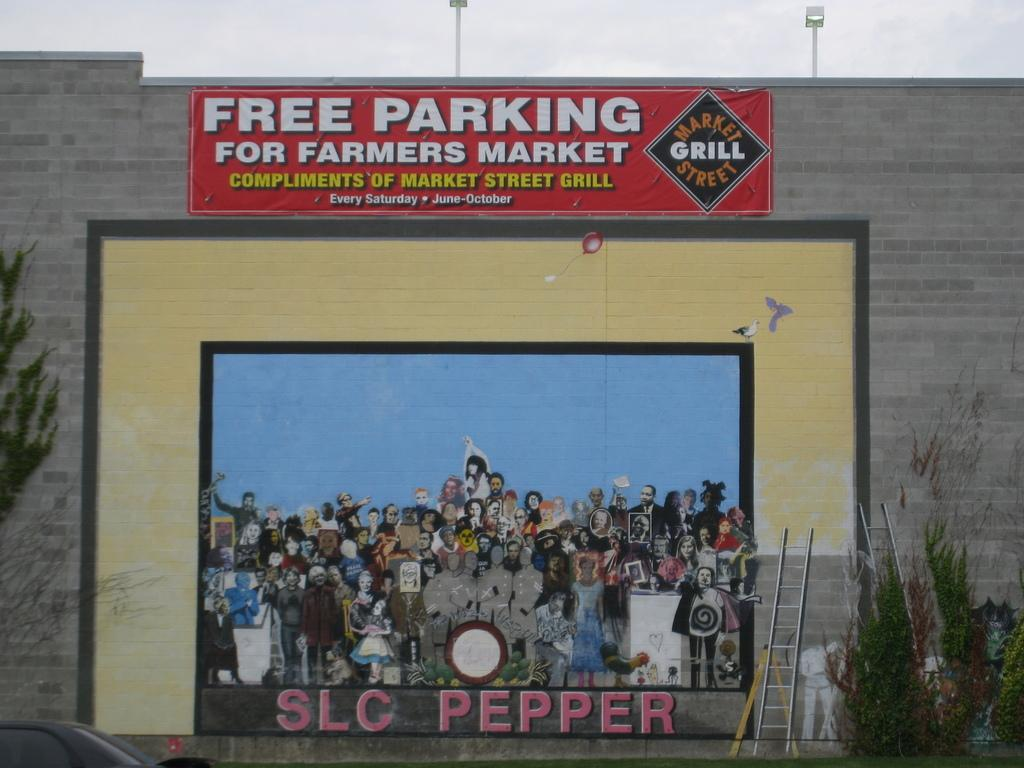<image>
Write a terse but informative summary of the picture. an album with SLC Pepper written at the bottom 